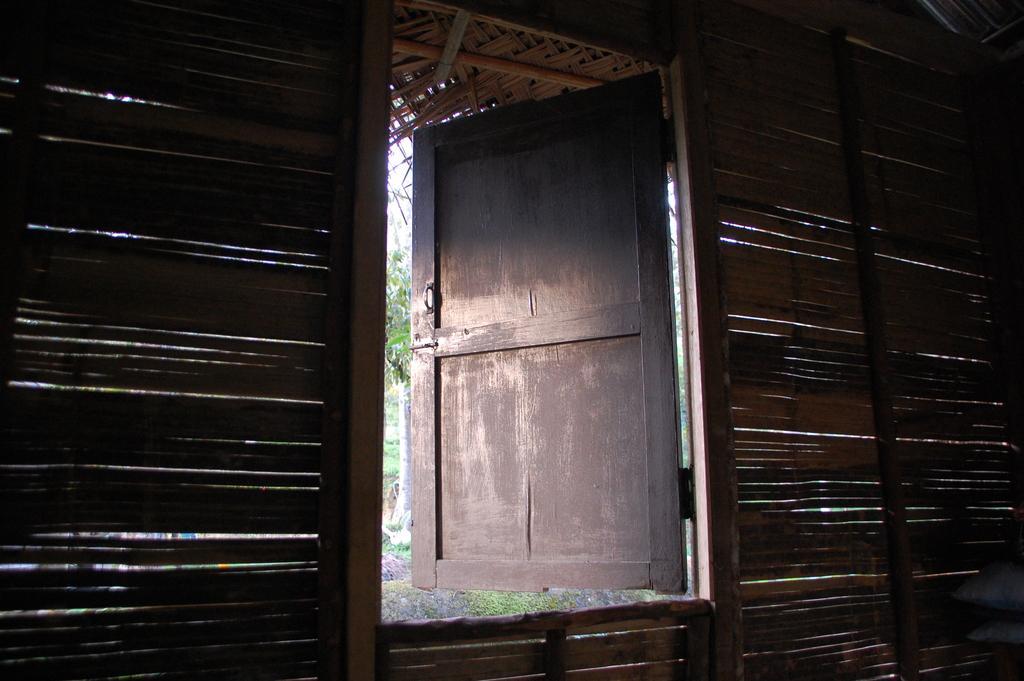Describe this image in one or two sentences. In the foreground of the picture there is a wooden wall and a door, outside the door there are plants and grass. 